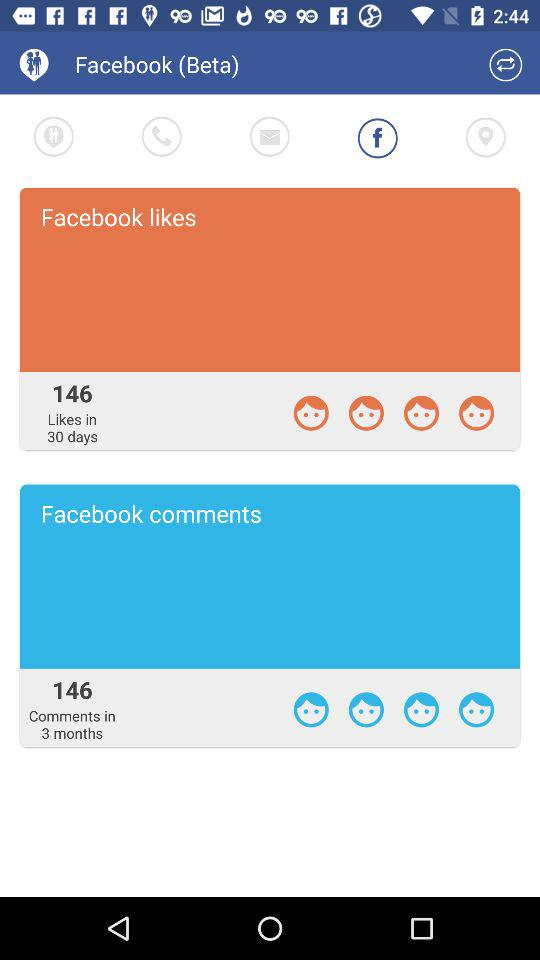In how many months do those comments come? Those comments come in 3 months. 